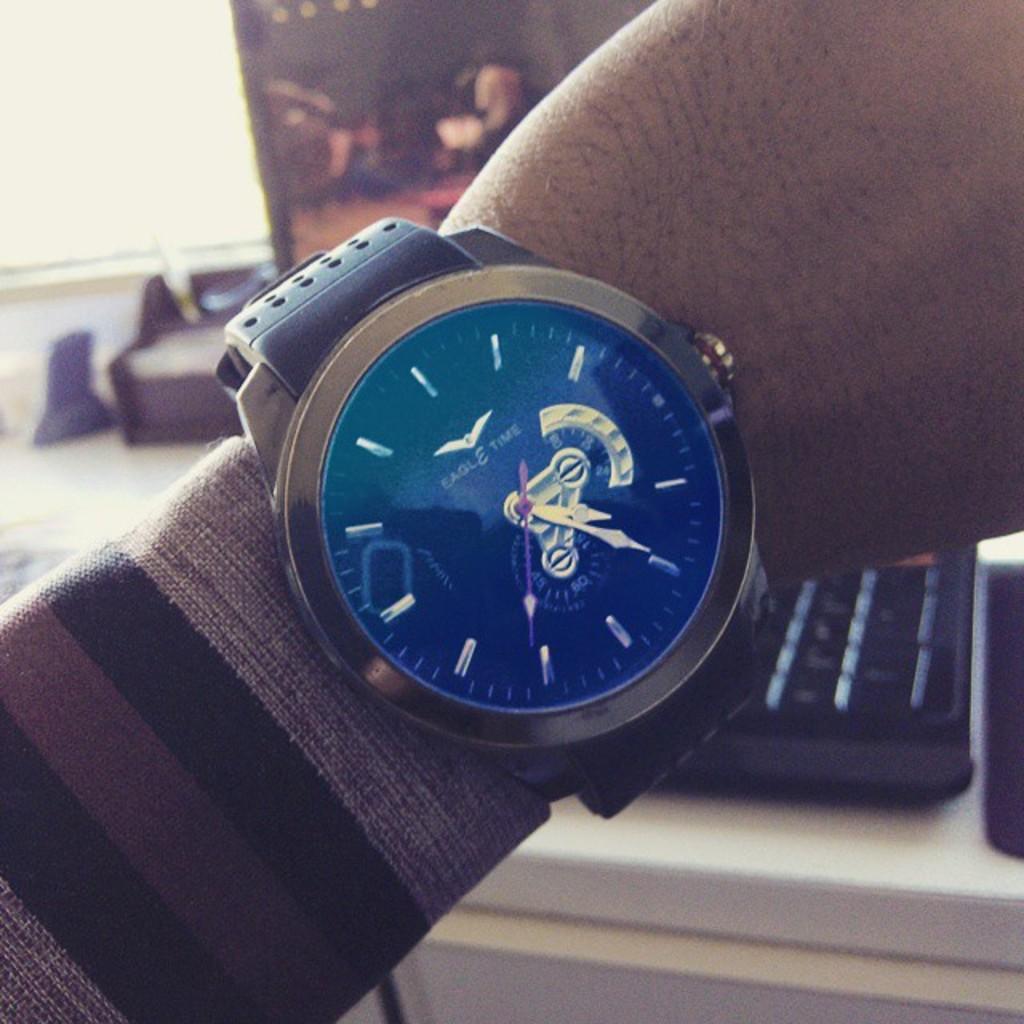What kind of watch is that?
Give a very brief answer. Eagle time. 